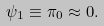<formula> <loc_0><loc_0><loc_500><loc_500>\psi _ { 1 } \equiv \pi _ { 0 } \approx 0 .</formula> 